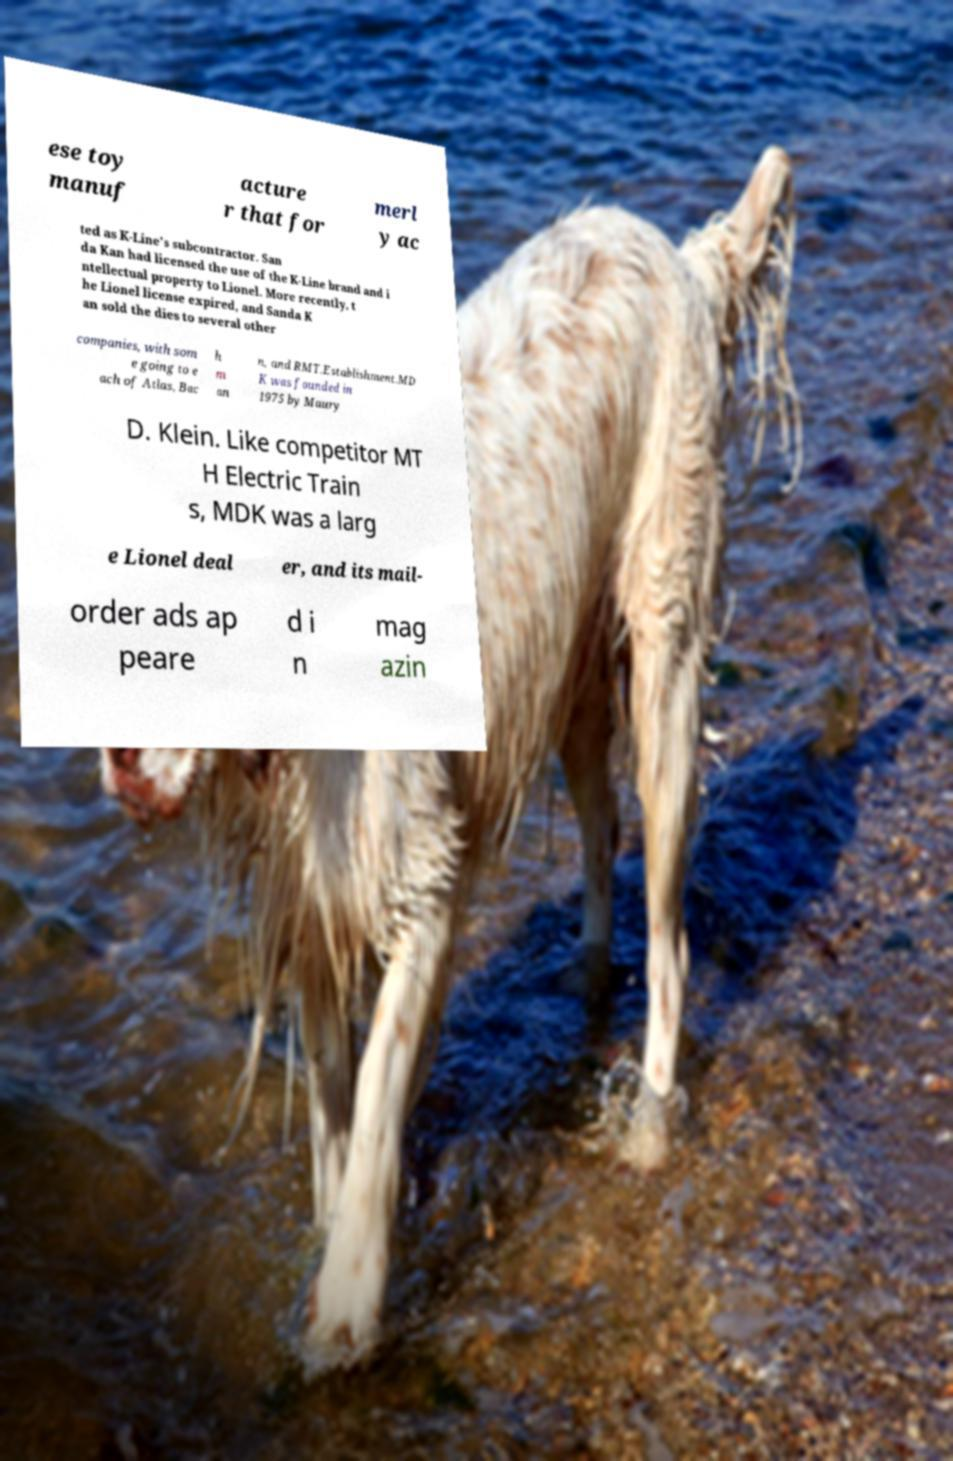I need the written content from this picture converted into text. Can you do that? ese toy manuf acture r that for merl y ac ted as K-Line's subcontractor. San da Kan had licensed the use of the K-Line brand and i ntellectual property to Lionel. More recently, t he Lionel license expired, and Sanda K an sold the dies to several other companies, with som e going to e ach of Atlas, Bac h m an n, and RMT.Establishment.MD K was founded in 1975 by Maury D. Klein. Like competitor MT H Electric Train s, MDK was a larg e Lionel deal er, and its mail- order ads ap peare d i n mag azin 